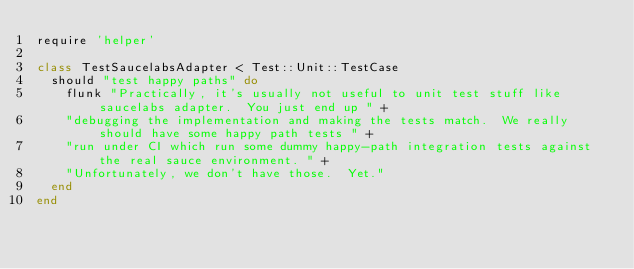<code> <loc_0><loc_0><loc_500><loc_500><_Ruby_>require 'helper'

class TestSaucelabsAdapter < Test::Unit::TestCase
  should "test happy paths" do
    flunk "Practically, it's usually not useful to unit test stuff like saucelabs adapter.  You just end up " +
    "debugging the implementation and making the tests match.  We really should have some happy path tests " +
    "run under CI which run some dummy happy-path integration tests against the real sauce environment. " +
    "Unfortunately, we don't have those.  Yet."
  end
end
</code> 